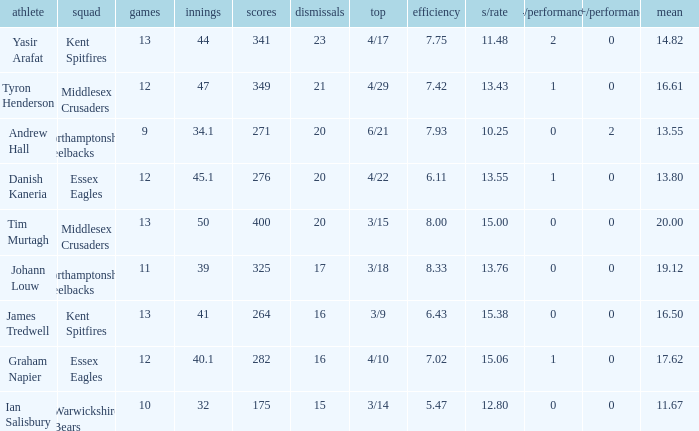Name the matches for wickets 17 11.0. 